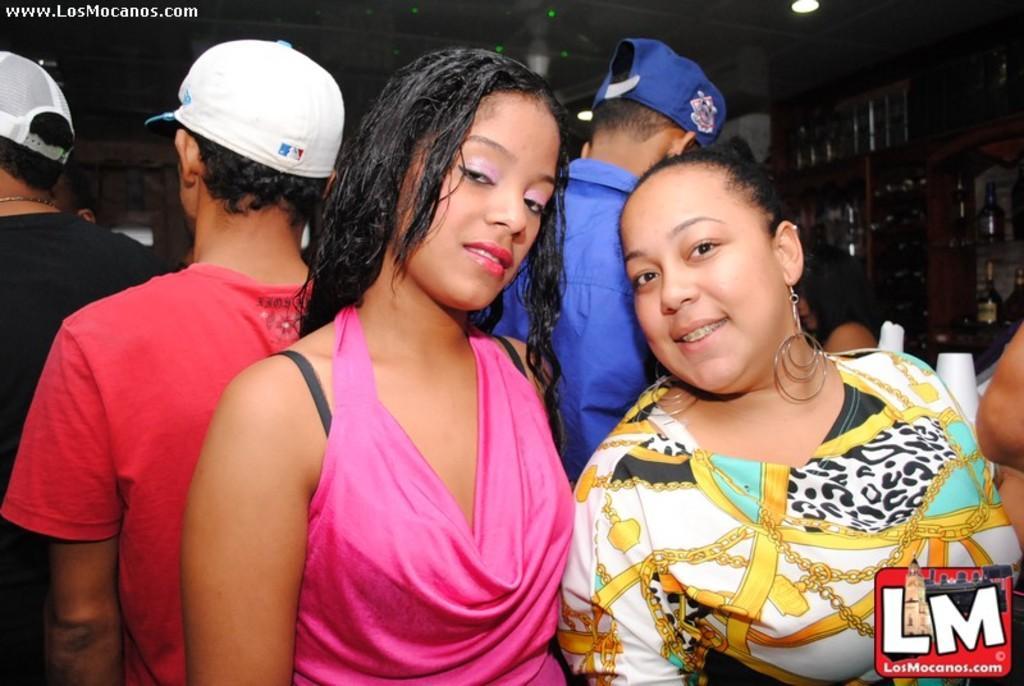Can you describe this image briefly? In the picture we can see two women are standing together, one woman is with pink dress and one woman is with long earrings and behind them, we can see three men with T-shirts and caps and beside them, we can see racks with wine bottles in it and to the ceiling we can see the light. 